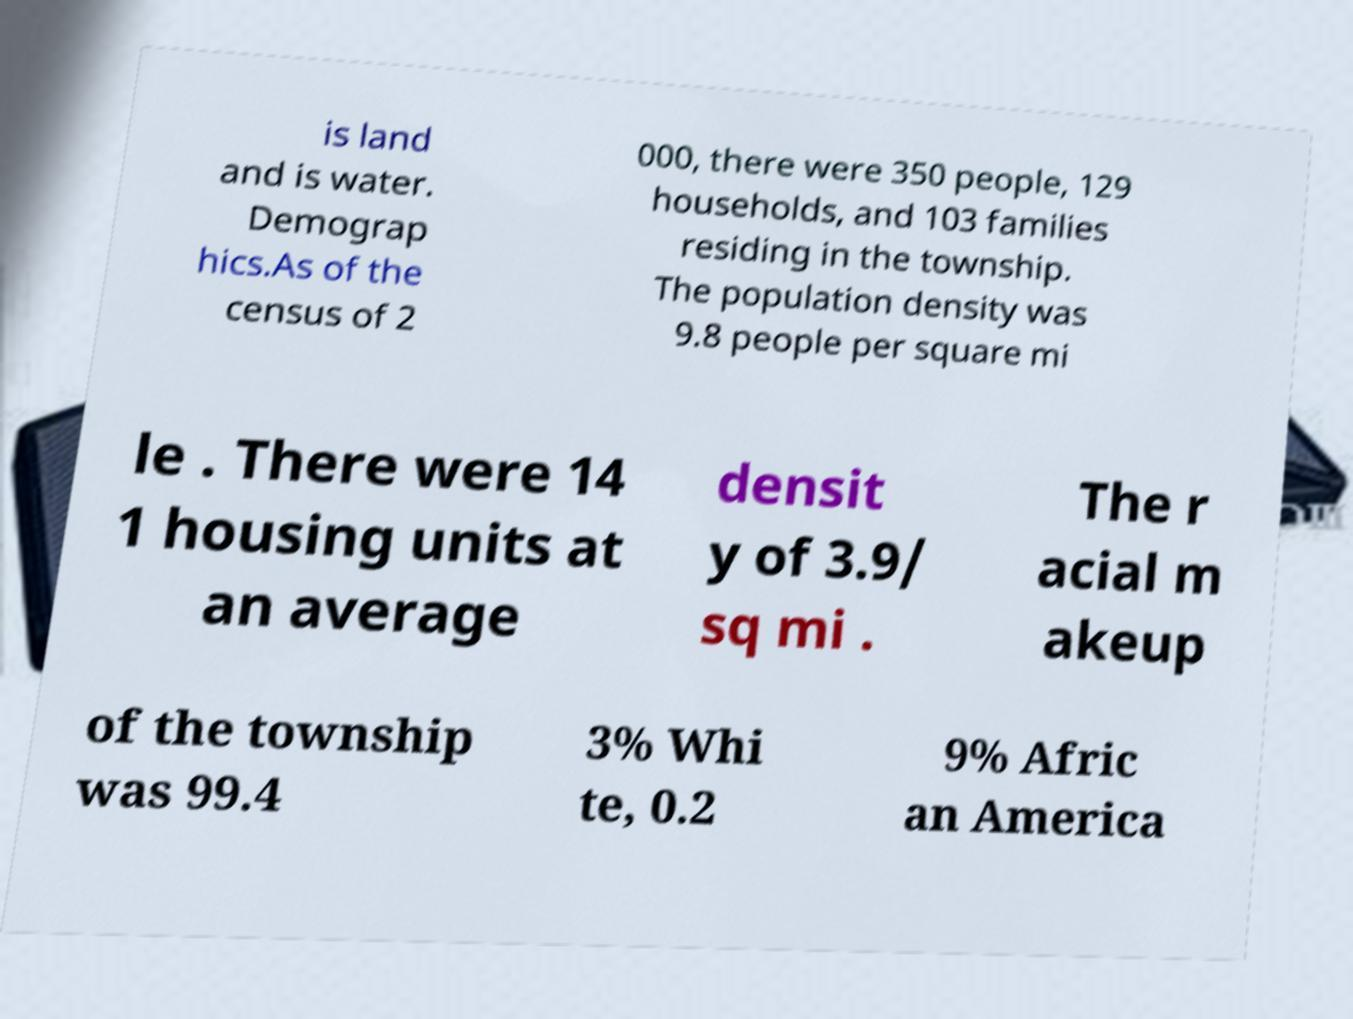There's text embedded in this image that I need extracted. Can you transcribe it verbatim? is land and is water. Demograp hics.As of the census of 2 000, there were 350 people, 129 households, and 103 families residing in the township. The population density was 9.8 people per square mi le . There were 14 1 housing units at an average densit y of 3.9/ sq mi . The r acial m akeup of the township was 99.4 3% Whi te, 0.2 9% Afric an America 